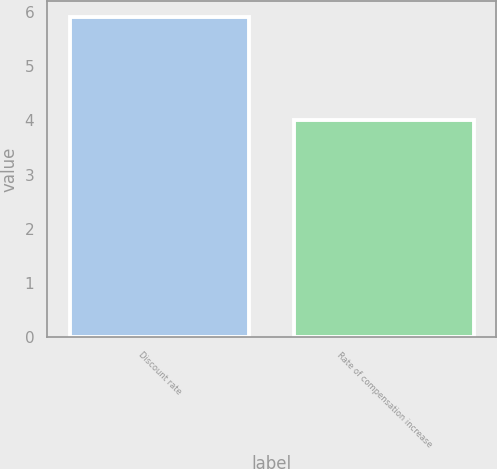Convert chart. <chart><loc_0><loc_0><loc_500><loc_500><bar_chart><fcel>Discount rate<fcel>Rate of compensation increase<nl><fcel>5.9<fcel>4<nl></chart> 